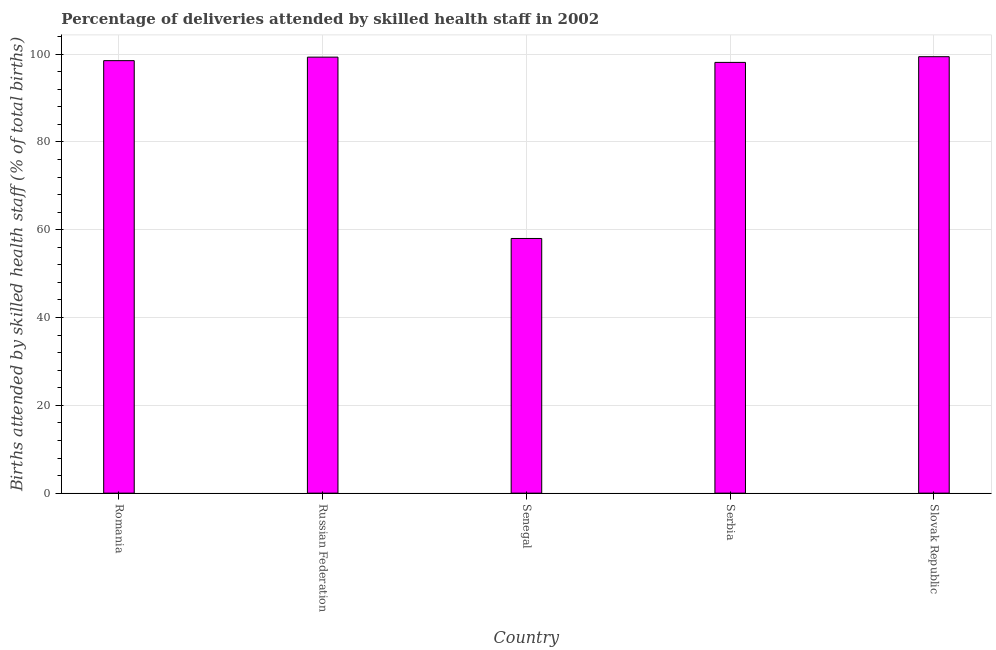What is the title of the graph?
Offer a terse response. Percentage of deliveries attended by skilled health staff in 2002. What is the label or title of the Y-axis?
Keep it short and to the point. Births attended by skilled health staff (% of total births). Across all countries, what is the maximum number of births attended by skilled health staff?
Offer a terse response. 99.4. In which country was the number of births attended by skilled health staff maximum?
Keep it short and to the point. Slovak Republic. In which country was the number of births attended by skilled health staff minimum?
Provide a succinct answer. Senegal. What is the sum of the number of births attended by skilled health staff?
Make the answer very short. 453.3. What is the average number of births attended by skilled health staff per country?
Ensure brevity in your answer.  90.66. What is the median number of births attended by skilled health staff?
Make the answer very short. 98.5. What is the ratio of the number of births attended by skilled health staff in Romania to that in Senegal?
Offer a terse response. 1.7. Is the difference between the number of births attended by skilled health staff in Russian Federation and Slovak Republic greater than the difference between any two countries?
Your response must be concise. No. What is the difference between the highest and the lowest number of births attended by skilled health staff?
Give a very brief answer. 41.4. In how many countries, is the number of births attended by skilled health staff greater than the average number of births attended by skilled health staff taken over all countries?
Keep it short and to the point. 4. How many bars are there?
Ensure brevity in your answer.  5. How many countries are there in the graph?
Make the answer very short. 5. What is the difference between two consecutive major ticks on the Y-axis?
Make the answer very short. 20. Are the values on the major ticks of Y-axis written in scientific E-notation?
Provide a short and direct response. No. What is the Births attended by skilled health staff (% of total births) of Romania?
Keep it short and to the point. 98.5. What is the Births attended by skilled health staff (% of total births) in Russian Federation?
Offer a very short reply. 99.3. What is the Births attended by skilled health staff (% of total births) in Serbia?
Give a very brief answer. 98.1. What is the Births attended by skilled health staff (% of total births) in Slovak Republic?
Your answer should be compact. 99.4. What is the difference between the Births attended by skilled health staff (% of total births) in Romania and Senegal?
Your answer should be very brief. 40.5. What is the difference between the Births attended by skilled health staff (% of total births) in Romania and Serbia?
Your answer should be compact. 0.4. What is the difference between the Births attended by skilled health staff (% of total births) in Russian Federation and Senegal?
Keep it short and to the point. 41.3. What is the difference between the Births attended by skilled health staff (% of total births) in Russian Federation and Slovak Republic?
Offer a very short reply. -0.1. What is the difference between the Births attended by skilled health staff (% of total births) in Senegal and Serbia?
Provide a succinct answer. -40.1. What is the difference between the Births attended by skilled health staff (% of total births) in Senegal and Slovak Republic?
Keep it short and to the point. -41.4. What is the ratio of the Births attended by skilled health staff (% of total births) in Romania to that in Russian Federation?
Your answer should be compact. 0.99. What is the ratio of the Births attended by skilled health staff (% of total births) in Romania to that in Senegal?
Keep it short and to the point. 1.7. What is the ratio of the Births attended by skilled health staff (% of total births) in Russian Federation to that in Senegal?
Your answer should be compact. 1.71. What is the ratio of the Births attended by skilled health staff (% of total births) in Russian Federation to that in Serbia?
Provide a succinct answer. 1.01. What is the ratio of the Births attended by skilled health staff (% of total births) in Russian Federation to that in Slovak Republic?
Keep it short and to the point. 1. What is the ratio of the Births attended by skilled health staff (% of total births) in Senegal to that in Serbia?
Provide a short and direct response. 0.59. What is the ratio of the Births attended by skilled health staff (% of total births) in Senegal to that in Slovak Republic?
Provide a short and direct response. 0.58. What is the ratio of the Births attended by skilled health staff (% of total births) in Serbia to that in Slovak Republic?
Give a very brief answer. 0.99. 